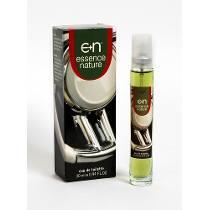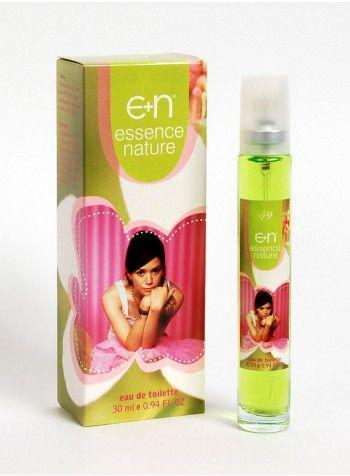The first image is the image on the left, the second image is the image on the right. Considering the images on both sides, is "A young woman is featured on the front of the bottle." valid? Answer yes or no. Yes. The first image is the image on the left, the second image is the image on the right. Analyze the images presented: Is the assertion "Both images shows a perfume box with a human being on it." valid? Answer yes or no. No. 